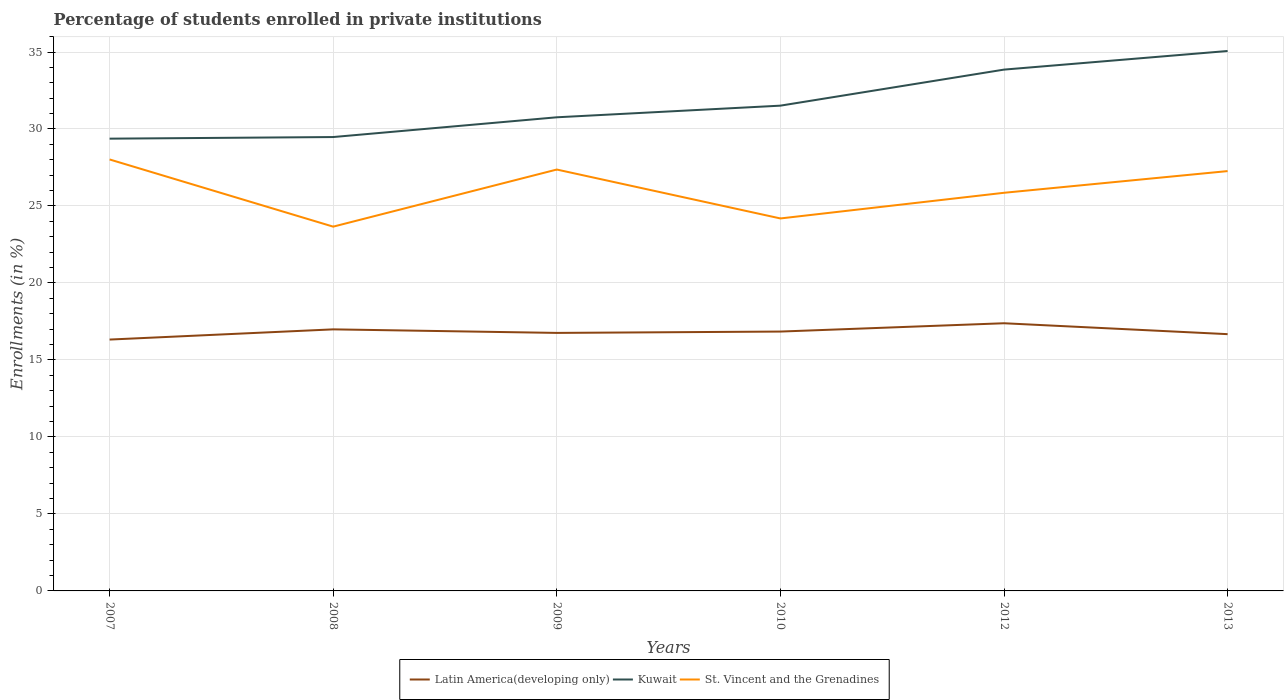How many different coloured lines are there?
Ensure brevity in your answer.  3. Does the line corresponding to Latin America(developing only) intersect with the line corresponding to Kuwait?
Provide a succinct answer. No. Across all years, what is the maximum percentage of trained teachers in Latin America(developing only)?
Give a very brief answer. 16.32. In which year was the percentage of trained teachers in St. Vincent and the Grenadines maximum?
Ensure brevity in your answer.  2008. What is the total percentage of trained teachers in Kuwait in the graph?
Provide a succinct answer. -2.04. What is the difference between the highest and the second highest percentage of trained teachers in Kuwait?
Ensure brevity in your answer.  5.69. How many lines are there?
Offer a terse response. 3. Does the graph contain grids?
Offer a very short reply. Yes. What is the title of the graph?
Give a very brief answer. Percentage of students enrolled in private institutions. What is the label or title of the X-axis?
Offer a very short reply. Years. What is the label or title of the Y-axis?
Your answer should be very brief. Enrollments (in %). What is the Enrollments (in %) of Latin America(developing only) in 2007?
Ensure brevity in your answer.  16.32. What is the Enrollments (in %) of Kuwait in 2007?
Give a very brief answer. 29.37. What is the Enrollments (in %) of St. Vincent and the Grenadines in 2007?
Offer a very short reply. 28.02. What is the Enrollments (in %) of Latin America(developing only) in 2008?
Offer a very short reply. 16.99. What is the Enrollments (in %) in Kuwait in 2008?
Provide a short and direct response. 29.48. What is the Enrollments (in %) in St. Vincent and the Grenadines in 2008?
Your answer should be compact. 23.66. What is the Enrollments (in %) of Latin America(developing only) in 2009?
Offer a terse response. 16.76. What is the Enrollments (in %) of Kuwait in 2009?
Give a very brief answer. 30.76. What is the Enrollments (in %) of St. Vincent and the Grenadines in 2009?
Ensure brevity in your answer.  27.37. What is the Enrollments (in %) in Latin America(developing only) in 2010?
Give a very brief answer. 16.84. What is the Enrollments (in %) of Kuwait in 2010?
Your answer should be compact. 31.52. What is the Enrollments (in %) in St. Vincent and the Grenadines in 2010?
Provide a short and direct response. 24.19. What is the Enrollments (in %) in Latin America(developing only) in 2012?
Make the answer very short. 17.38. What is the Enrollments (in %) of Kuwait in 2012?
Provide a short and direct response. 33.86. What is the Enrollments (in %) in St. Vincent and the Grenadines in 2012?
Provide a short and direct response. 25.86. What is the Enrollments (in %) in Latin America(developing only) in 2013?
Provide a succinct answer. 16.68. What is the Enrollments (in %) of Kuwait in 2013?
Make the answer very short. 35.06. What is the Enrollments (in %) in St. Vincent and the Grenadines in 2013?
Your answer should be very brief. 27.27. Across all years, what is the maximum Enrollments (in %) of Latin America(developing only)?
Provide a succinct answer. 17.38. Across all years, what is the maximum Enrollments (in %) of Kuwait?
Keep it short and to the point. 35.06. Across all years, what is the maximum Enrollments (in %) in St. Vincent and the Grenadines?
Offer a very short reply. 28.02. Across all years, what is the minimum Enrollments (in %) in Latin America(developing only)?
Provide a short and direct response. 16.32. Across all years, what is the minimum Enrollments (in %) in Kuwait?
Your answer should be compact. 29.37. Across all years, what is the minimum Enrollments (in %) in St. Vincent and the Grenadines?
Offer a very short reply. 23.66. What is the total Enrollments (in %) in Latin America(developing only) in the graph?
Your response must be concise. 100.97. What is the total Enrollments (in %) in Kuwait in the graph?
Keep it short and to the point. 190.05. What is the total Enrollments (in %) of St. Vincent and the Grenadines in the graph?
Give a very brief answer. 156.36. What is the difference between the Enrollments (in %) of Latin America(developing only) in 2007 and that in 2008?
Your answer should be very brief. -0.66. What is the difference between the Enrollments (in %) of Kuwait in 2007 and that in 2008?
Ensure brevity in your answer.  -0.1. What is the difference between the Enrollments (in %) of St. Vincent and the Grenadines in 2007 and that in 2008?
Offer a very short reply. 4.36. What is the difference between the Enrollments (in %) in Latin America(developing only) in 2007 and that in 2009?
Make the answer very short. -0.43. What is the difference between the Enrollments (in %) of Kuwait in 2007 and that in 2009?
Keep it short and to the point. -1.39. What is the difference between the Enrollments (in %) of St. Vincent and the Grenadines in 2007 and that in 2009?
Your answer should be very brief. 0.65. What is the difference between the Enrollments (in %) in Latin America(developing only) in 2007 and that in 2010?
Provide a short and direct response. -0.52. What is the difference between the Enrollments (in %) of Kuwait in 2007 and that in 2010?
Offer a very short reply. -2.14. What is the difference between the Enrollments (in %) in St. Vincent and the Grenadines in 2007 and that in 2010?
Provide a succinct answer. 3.83. What is the difference between the Enrollments (in %) of Latin America(developing only) in 2007 and that in 2012?
Your response must be concise. -1.06. What is the difference between the Enrollments (in %) in Kuwait in 2007 and that in 2012?
Your answer should be compact. -4.48. What is the difference between the Enrollments (in %) in St. Vincent and the Grenadines in 2007 and that in 2012?
Give a very brief answer. 2.16. What is the difference between the Enrollments (in %) of Latin America(developing only) in 2007 and that in 2013?
Provide a short and direct response. -0.35. What is the difference between the Enrollments (in %) of Kuwait in 2007 and that in 2013?
Make the answer very short. -5.69. What is the difference between the Enrollments (in %) in St. Vincent and the Grenadines in 2007 and that in 2013?
Ensure brevity in your answer.  0.76. What is the difference between the Enrollments (in %) in Latin America(developing only) in 2008 and that in 2009?
Your answer should be very brief. 0.23. What is the difference between the Enrollments (in %) of Kuwait in 2008 and that in 2009?
Your response must be concise. -1.28. What is the difference between the Enrollments (in %) of St. Vincent and the Grenadines in 2008 and that in 2009?
Provide a short and direct response. -3.71. What is the difference between the Enrollments (in %) in Latin America(developing only) in 2008 and that in 2010?
Give a very brief answer. 0.14. What is the difference between the Enrollments (in %) of Kuwait in 2008 and that in 2010?
Provide a succinct answer. -2.04. What is the difference between the Enrollments (in %) of St. Vincent and the Grenadines in 2008 and that in 2010?
Give a very brief answer. -0.53. What is the difference between the Enrollments (in %) in Latin America(developing only) in 2008 and that in 2012?
Give a very brief answer. -0.4. What is the difference between the Enrollments (in %) in Kuwait in 2008 and that in 2012?
Make the answer very short. -4.38. What is the difference between the Enrollments (in %) of St. Vincent and the Grenadines in 2008 and that in 2012?
Your answer should be very brief. -2.2. What is the difference between the Enrollments (in %) in Latin America(developing only) in 2008 and that in 2013?
Your response must be concise. 0.31. What is the difference between the Enrollments (in %) of Kuwait in 2008 and that in 2013?
Provide a succinct answer. -5.59. What is the difference between the Enrollments (in %) in St. Vincent and the Grenadines in 2008 and that in 2013?
Make the answer very short. -3.61. What is the difference between the Enrollments (in %) of Latin America(developing only) in 2009 and that in 2010?
Make the answer very short. -0.09. What is the difference between the Enrollments (in %) in Kuwait in 2009 and that in 2010?
Offer a terse response. -0.76. What is the difference between the Enrollments (in %) of St. Vincent and the Grenadines in 2009 and that in 2010?
Provide a succinct answer. 3.18. What is the difference between the Enrollments (in %) in Latin America(developing only) in 2009 and that in 2012?
Offer a terse response. -0.63. What is the difference between the Enrollments (in %) in Kuwait in 2009 and that in 2012?
Provide a short and direct response. -3.1. What is the difference between the Enrollments (in %) of St. Vincent and the Grenadines in 2009 and that in 2012?
Offer a very short reply. 1.51. What is the difference between the Enrollments (in %) in Latin America(developing only) in 2009 and that in 2013?
Your response must be concise. 0.08. What is the difference between the Enrollments (in %) of Kuwait in 2009 and that in 2013?
Offer a very short reply. -4.3. What is the difference between the Enrollments (in %) of St. Vincent and the Grenadines in 2009 and that in 2013?
Provide a short and direct response. 0.1. What is the difference between the Enrollments (in %) of Latin America(developing only) in 2010 and that in 2012?
Ensure brevity in your answer.  -0.54. What is the difference between the Enrollments (in %) of Kuwait in 2010 and that in 2012?
Make the answer very short. -2.34. What is the difference between the Enrollments (in %) of St. Vincent and the Grenadines in 2010 and that in 2012?
Ensure brevity in your answer.  -1.67. What is the difference between the Enrollments (in %) in Latin America(developing only) in 2010 and that in 2013?
Offer a very short reply. 0.17. What is the difference between the Enrollments (in %) in Kuwait in 2010 and that in 2013?
Your answer should be compact. -3.55. What is the difference between the Enrollments (in %) of St. Vincent and the Grenadines in 2010 and that in 2013?
Provide a succinct answer. -3.08. What is the difference between the Enrollments (in %) in Latin America(developing only) in 2012 and that in 2013?
Offer a terse response. 0.71. What is the difference between the Enrollments (in %) in Kuwait in 2012 and that in 2013?
Give a very brief answer. -1.21. What is the difference between the Enrollments (in %) of St. Vincent and the Grenadines in 2012 and that in 2013?
Your answer should be compact. -1.41. What is the difference between the Enrollments (in %) of Latin America(developing only) in 2007 and the Enrollments (in %) of Kuwait in 2008?
Your answer should be compact. -13.15. What is the difference between the Enrollments (in %) in Latin America(developing only) in 2007 and the Enrollments (in %) in St. Vincent and the Grenadines in 2008?
Make the answer very short. -7.33. What is the difference between the Enrollments (in %) in Kuwait in 2007 and the Enrollments (in %) in St. Vincent and the Grenadines in 2008?
Provide a short and direct response. 5.71. What is the difference between the Enrollments (in %) of Latin America(developing only) in 2007 and the Enrollments (in %) of Kuwait in 2009?
Make the answer very short. -14.44. What is the difference between the Enrollments (in %) in Latin America(developing only) in 2007 and the Enrollments (in %) in St. Vincent and the Grenadines in 2009?
Ensure brevity in your answer.  -11.04. What is the difference between the Enrollments (in %) of Kuwait in 2007 and the Enrollments (in %) of St. Vincent and the Grenadines in 2009?
Your response must be concise. 2.01. What is the difference between the Enrollments (in %) of Latin America(developing only) in 2007 and the Enrollments (in %) of Kuwait in 2010?
Keep it short and to the point. -15.19. What is the difference between the Enrollments (in %) of Latin America(developing only) in 2007 and the Enrollments (in %) of St. Vincent and the Grenadines in 2010?
Ensure brevity in your answer.  -7.87. What is the difference between the Enrollments (in %) of Kuwait in 2007 and the Enrollments (in %) of St. Vincent and the Grenadines in 2010?
Give a very brief answer. 5.18. What is the difference between the Enrollments (in %) in Latin America(developing only) in 2007 and the Enrollments (in %) in Kuwait in 2012?
Provide a succinct answer. -17.53. What is the difference between the Enrollments (in %) in Latin America(developing only) in 2007 and the Enrollments (in %) in St. Vincent and the Grenadines in 2012?
Make the answer very short. -9.53. What is the difference between the Enrollments (in %) of Kuwait in 2007 and the Enrollments (in %) of St. Vincent and the Grenadines in 2012?
Make the answer very short. 3.52. What is the difference between the Enrollments (in %) of Latin America(developing only) in 2007 and the Enrollments (in %) of Kuwait in 2013?
Make the answer very short. -18.74. What is the difference between the Enrollments (in %) of Latin America(developing only) in 2007 and the Enrollments (in %) of St. Vincent and the Grenadines in 2013?
Your response must be concise. -10.94. What is the difference between the Enrollments (in %) of Kuwait in 2007 and the Enrollments (in %) of St. Vincent and the Grenadines in 2013?
Your response must be concise. 2.11. What is the difference between the Enrollments (in %) of Latin America(developing only) in 2008 and the Enrollments (in %) of Kuwait in 2009?
Your answer should be very brief. -13.77. What is the difference between the Enrollments (in %) in Latin America(developing only) in 2008 and the Enrollments (in %) in St. Vincent and the Grenadines in 2009?
Provide a short and direct response. -10.38. What is the difference between the Enrollments (in %) of Kuwait in 2008 and the Enrollments (in %) of St. Vincent and the Grenadines in 2009?
Your response must be concise. 2.11. What is the difference between the Enrollments (in %) in Latin America(developing only) in 2008 and the Enrollments (in %) in Kuwait in 2010?
Offer a very short reply. -14.53. What is the difference between the Enrollments (in %) of Latin America(developing only) in 2008 and the Enrollments (in %) of St. Vincent and the Grenadines in 2010?
Make the answer very short. -7.2. What is the difference between the Enrollments (in %) in Kuwait in 2008 and the Enrollments (in %) in St. Vincent and the Grenadines in 2010?
Keep it short and to the point. 5.29. What is the difference between the Enrollments (in %) of Latin America(developing only) in 2008 and the Enrollments (in %) of Kuwait in 2012?
Make the answer very short. -16.87. What is the difference between the Enrollments (in %) in Latin America(developing only) in 2008 and the Enrollments (in %) in St. Vincent and the Grenadines in 2012?
Provide a short and direct response. -8.87. What is the difference between the Enrollments (in %) of Kuwait in 2008 and the Enrollments (in %) of St. Vincent and the Grenadines in 2012?
Ensure brevity in your answer.  3.62. What is the difference between the Enrollments (in %) in Latin America(developing only) in 2008 and the Enrollments (in %) in Kuwait in 2013?
Give a very brief answer. -18.08. What is the difference between the Enrollments (in %) in Latin America(developing only) in 2008 and the Enrollments (in %) in St. Vincent and the Grenadines in 2013?
Provide a succinct answer. -10.28. What is the difference between the Enrollments (in %) in Kuwait in 2008 and the Enrollments (in %) in St. Vincent and the Grenadines in 2013?
Offer a terse response. 2.21. What is the difference between the Enrollments (in %) in Latin America(developing only) in 2009 and the Enrollments (in %) in Kuwait in 2010?
Ensure brevity in your answer.  -14.76. What is the difference between the Enrollments (in %) of Latin America(developing only) in 2009 and the Enrollments (in %) of St. Vincent and the Grenadines in 2010?
Provide a succinct answer. -7.43. What is the difference between the Enrollments (in %) in Kuwait in 2009 and the Enrollments (in %) in St. Vincent and the Grenadines in 2010?
Offer a very short reply. 6.57. What is the difference between the Enrollments (in %) in Latin America(developing only) in 2009 and the Enrollments (in %) in Kuwait in 2012?
Provide a short and direct response. -17.1. What is the difference between the Enrollments (in %) in Latin America(developing only) in 2009 and the Enrollments (in %) in St. Vincent and the Grenadines in 2012?
Keep it short and to the point. -9.1. What is the difference between the Enrollments (in %) in Kuwait in 2009 and the Enrollments (in %) in St. Vincent and the Grenadines in 2012?
Your answer should be very brief. 4.9. What is the difference between the Enrollments (in %) of Latin America(developing only) in 2009 and the Enrollments (in %) of Kuwait in 2013?
Keep it short and to the point. -18.31. What is the difference between the Enrollments (in %) in Latin America(developing only) in 2009 and the Enrollments (in %) in St. Vincent and the Grenadines in 2013?
Your response must be concise. -10.51. What is the difference between the Enrollments (in %) of Kuwait in 2009 and the Enrollments (in %) of St. Vincent and the Grenadines in 2013?
Give a very brief answer. 3.49. What is the difference between the Enrollments (in %) of Latin America(developing only) in 2010 and the Enrollments (in %) of Kuwait in 2012?
Offer a terse response. -17.01. What is the difference between the Enrollments (in %) of Latin America(developing only) in 2010 and the Enrollments (in %) of St. Vincent and the Grenadines in 2012?
Offer a terse response. -9.01. What is the difference between the Enrollments (in %) in Kuwait in 2010 and the Enrollments (in %) in St. Vincent and the Grenadines in 2012?
Your answer should be very brief. 5.66. What is the difference between the Enrollments (in %) in Latin America(developing only) in 2010 and the Enrollments (in %) in Kuwait in 2013?
Your response must be concise. -18.22. What is the difference between the Enrollments (in %) in Latin America(developing only) in 2010 and the Enrollments (in %) in St. Vincent and the Grenadines in 2013?
Your answer should be compact. -10.42. What is the difference between the Enrollments (in %) of Kuwait in 2010 and the Enrollments (in %) of St. Vincent and the Grenadines in 2013?
Your response must be concise. 4.25. What is the difference between the Enrollments (in %) of Latin America(developing only) in 2012 and the Enrollments (in %) of Kuwait in 2013?
Make the answer very short. -17.68. What is the difference between the Enrollments (in %) of Latin America(developing only) in 2012 and the Enrollments (in %) of St. Vincent and the Grenadines in 2013?
Your response must be concise. -9.88. What is the difference between the Enrollments (in %) of Kuwait in 2012 and the Enrollments (in %) of St. Vincent and the Grenadines in 2013?
Ensure brevity in your answer.  6.59. What is the average Enrollments (in %) of Latin America(developing only) per year?
Keep it short and to the point. 16.83. What is the average Enrollments (in %) of Kuwait per year?
Provide a succinct answer. 31.67. What is the average Enrollments (in %) in St. Vincent and the Grenadines per year?
Provide a short and direct response. 26.06. In the year 2007, what is the difference between the Enrollments (in %) of Latin America(developing only) and Enrollments (in %) of Kuwait?
Your answer should be very brief. -13.05. In the year 2007, what is the difference between the Enrollments (in %) of Latin America(developing only) and Enrollments (in %) of St. Vincent and the Grenadines?
Make the answer very short. -11.7. In the year 2007, what is the difference between the Enrollments (in %) in Kuwait and Enrollments (in %) in St. Vincent and the Grenadines?
Make the answer very short. 1.35. In the year 2008, what is the difference between the Enrollments (in %) of Latin America(developing only) and Enrollments (in %) of Kuwait?
Your answer should be compact. -12.49. In the year 2008, what is the difference between the Enrollments (in %) in Latin America(developing only) and Enrollments (in %) in St. Vincent and the Grenadines?
Provide a succinct answer. -6.67. In the year 2008, what is the difference between the Enrollments (in %) of Kuwait and Enrollments (in %) of St. Vincent and the Grenadines?
Your answer should be compact. 5.82. In the year 2009, what is the difference between the Enrollments (in %) of Latin America(developing only) and Enrollments (in %) of Kuwait?
Keep it short and to the point. -14. In the year 2009, what is the difference between the Enrollments (in %) in Latin America(developing only) and Enrollments (in %) in St. Vincent and the Grenadines?
Your answer should be very brief. -10.61. In the year 2009, what is the difference between the Enrollments (in %) in Kuwait and Enrollments (in %) in St. Vincent and the Grenadines?
Provide a short and direct response. 3.39. In the year 2010, what is the difference between the Enrollments (in %) in Latin America(developing only) and Enrollments (in %) in Kuwait?
Provide a succinct answer. -14.67. In the year 2010, what is the difference between the Enrollments (in %) of Latin America(developing only) and Enrollments (in %) of St. Vincent and the Grenadines?
Your response must be concise. -7.35. In the year 2010, what is the difference between the Enrollments (in %) of Kuwait and Enrollments (in %) of St. Vincent and the Grenadines?
Your answer should be very brief. 7.33. In the year 2012, what is the difference between the Enrollments (in %) in Latin America(developing only) and Enrollments (in %) in Kuwait?
Provide a short and direct response. -16.47. In the year 2012, what is the difference between the Enrollments (in %) of Latin America(developing only) and Enrollments (in %) of St. Vincent and the Grenadines?
Provide a succinct answer. -8.47. In the year 2012, what is the difference between the Enrollments (in %) in Kuwait and Enrollments (in %) in St. Vincent and the Grenadines?
Give a very brief answer. 8. In the year 2013, what is the difference between the Enrollments (in %) in Latin America(developing only) and Enrollments (in %) in Kuwait?
Your answer should be very brief. -18.39. In the year 2013, what is the difference between the Enrollments (in %) in Latin America(developing only) and Enrollments (in %) in St. Vincent and the Grenadines?
Ensure brevity in your answer.  -10.59. In the year 2013, what is the difference between the Enrollments (in %) of Kuwait and Enrollments (in %) of St. Vincent and the Grenadines?
Ensure brevity in your answer.  7.8. What is the ratio of the Enrollments (in %) in Kuwait in 2007 to that in 2008?
Your response must be concise. 1. What is the ratio of the Enrollments (in %) of St. Vincent and the Grenadines in 2007 to that in 2008?
Your answer should be very brief. 1.18. What is the ratio of the Enrollments (in %) in Latin America(developing only) in 2007 to that in 2009?
Keep it short and to the point. 0.97. What is the ratio of the Enrollments (in %) of Kuwait in 2007 to that in 2009?
Ensure brevity in your answer.  0.95. What is the ratio of the Enrollments (in %) of St. Vincent and the Grenadines in 2007 to that in 2009?
Your answer should be very brief. 1.02. What is the ratio of the Enrollments (in %) of Latin America(developing only) in 2007 to that in 2010?
Offer a very short reply. 0.97. What is the ratio of the Enrollments (in %) in Kuwait in 2007 to that in 2010?
Your answer should be very brief. 0.93. What is the ratio of the Enrollments (in %) of St. Vincent and the Grenadines in 2007 to that in 2010?
Your answer should be compact. 1.16. What is the ratio of the Enrollments (in %) in Latin America(developing only) in 2007 to that in 2012?
Provide a short and direct response. 0.94. What is the ratio of the Enrollments (in %) in Kuwait in 2007 to that in 2012?
Ensure brevity in your answer.  0.87. What is the ratio of the Enrollments (in %) of St. Vincent and the Grenadines in 2007 to that in 2012?
Your answer should be compact. 1.08. What is the ratio of the Enrollments (in %) of Latin America(developing only) in 2007 to that in 2013?
Your answer should be very brief. 0.98. What is the ratio of the Enrollments (in %) in Kuwait in 2007 to that in 2013?
Your response must be concise. 0.84. What is the ratio of the Enrollments (in %) of St. Vincent and the Grenadines in 2007 to that in 2013?
Keep it short and to the point. 1.03. What is the ratio of the Enrollments (in %) in Latin America(developing only) in 2008 to that in 2009?
Keep it short and to the point. 1.01. What is the ratio of the Enrollments (in %) in St. Vincent and the Grenadines in 2008 to that in 2009?
Offer a terse response. 0.86. What is the ratio of the Enrollments (in %) in Latin America(developing only) in 2008 to that in 2010?
Offer a terse response. 1.01. What is the ratio of the Enrollments (in %) in Kuwait in 2008 to that in 2010?
Give a very brief answer. 0.94. What is the ratio of the Enrollments (in %) of Latin America(developing only) in 2008 to that in 2012?
Your answer should be compact. 0.98. What is the ratio of the Enrollments (in %) of Kuwait in 2008 to that in 2012?
Provide a succinct answer. 0.87. What is the ratio of the Enrollments (in %) in St. Vincent and the Grenadines in 2008 to that in 2012?
Make the answer very short. 0.92. What is the ratio of the Enrollments (in %) of Latin America(developing only) in 2008 to that in 2013?
Ensure brevity in your answer.  1.02. What is the ratio of the Enrollments (in %) of Kuwait in 2008 to that in 2013?
Keep it short and to the point. 0.84. What is the ratio of the Enrollments (in %) of St. Vincent and the Grenadines in 2008 to that in 2013?
Your response must be concise. 0.87. What is the ratio of the Enrollments (in %) in Latin America(developing only) in 2009 to that in 2010?
Provide a short and direct response. 0.99. What is the ratio of the Enrollments (in %) in Kuwait in 2009 to that in 2010?
Provide a succinct answer. 0.98. What is the ratio of the Enrollments (in %) of St. Vincent and the Grenadines in 2009 to that in 2010?
Offer a very short reply. 1.13. What is the ratio of the Enrollments (in %) of Latin America(developing only) in 2009 to that in 2012?
Make the answer very short. 0.96. What is the ratio of the Enrollments (in %) of Kuwait in 2009 to that in 2012?
Your response must be concise. 0.91. What is the ratio of the Enrollments (in %) of St. Vincent and the Grenadines in 2009 to that in 2012?
Offer a very short reply. 1.06. What is the ratio of the Enrollments (in %) in Kuwait in 2009 to that in 2013?
Your response must be concise. 0.88. What is the ratio of the Enrollments (in %) in St. Vincent and the Grenadines in 2009 to that in 2013?
Keep it short and to the point. 1. What is the ratio of the Enrollments (in %) of Latin America(developing only) in 2010 to that in 2012?
Give a very brief answer. 0.97. What is the ratio of the Enrollments (in %) in Kuwait in 2010 to that in 2012?
Offer a terse response. 0.93. What is the ratio of the Enrollments (in %) of St. Vincent and the Grenadines in 2010 to that in 2012?
Offer a terse response. 0.94. What is the ratio of the Enrollments (in %) in Kuwait in 2010 to that in 2013?
Keep it short and to the point. 0.9. What is the ratio of the Enrollments (in %) of St. Vincent and the Grenadines in 2010 to that in 2013?
Make the answer very short. 0.89. What is the ratio of the Enrollments (in %) of Latin America(developing only) in 2012 to that in 2013?
Keep it short and to the point. 1.04. What is the ratio of the Enrollments (in %) of Kuwait in 2012 to that in 2013?
Provide a short and direct response. 0.97. What is the ratio of the Enrollments (in %) of St. Vincent and the Grenadines in 2012 to that in 2013?
Your response must be concise. 0.95. What is the difference between the highest and the second highest Enrollments (in %) of Latin America(developing only)?
Your response must be concise. 0.4. What is the difference between the highest and the second highest Enrollments (in %) in Kuwait?
Offer a very short reply. 1.21. What is the difference between the highest and the second highest Enrollments (in %) of St. Vincent and the Grenadines?
Provide a short and direct response. 0.65. What is the difference between the highest and the lowest Enrollments (in %) in Latin America(developing only)?
Provide a succinct answer. 1.06. What is the difference between the highest and the lowest Enrollments (in %) in Kuwait?
Give a very brief answer. 5.69. What is the difference between the highest and the lowest Enrollments (in %) in St. Vincent and the Grenadines?
Offer a very short reply. 4.36. 